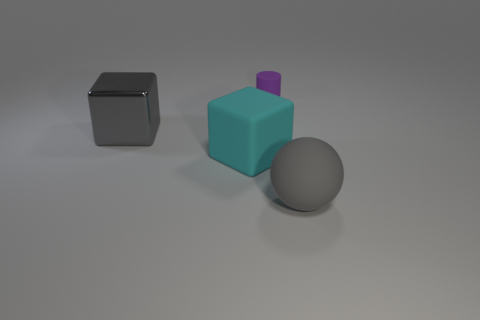What number of cyan matte objects are the same size as the ball?
Your answer should be compact. 1. Is there a tiny cylinder?
Your answer should be very brief. Yes. Are there any other things that are the same color as the metallic block?
Your response must be concise. Yes. What is the shape of the large gray object that is made of the same material as the small purple object?
Your response must be concise. Sphere. What color is the big block that is to the right of the big shiny object in front of the rubber thing that is behind the large shiny thing?
Offer a very short reply. Cyan. Is the number of cyan objects that are in front of the gray sphere the same as the number of big cyan matte cylinders?
Provide a short and direct response. Yes. Is there anything else that is made of the same material as the big gray cube?
Ensure brevity in your answer.  No. Does the large shiny cube have the same color as the large matte object to the right of the small purple cylinder?
Your answer should be compact. Yes. There is a gray thing that is behind the large gray object in front of the large gray metallic object; is there a tiny purple rubber thing behind it?
Keep it short and to the point. Yes. Is the number of large cyan rubber things left of the big cyan matte object less than the number of gray things?
Keep it short and to the point. Yes. 